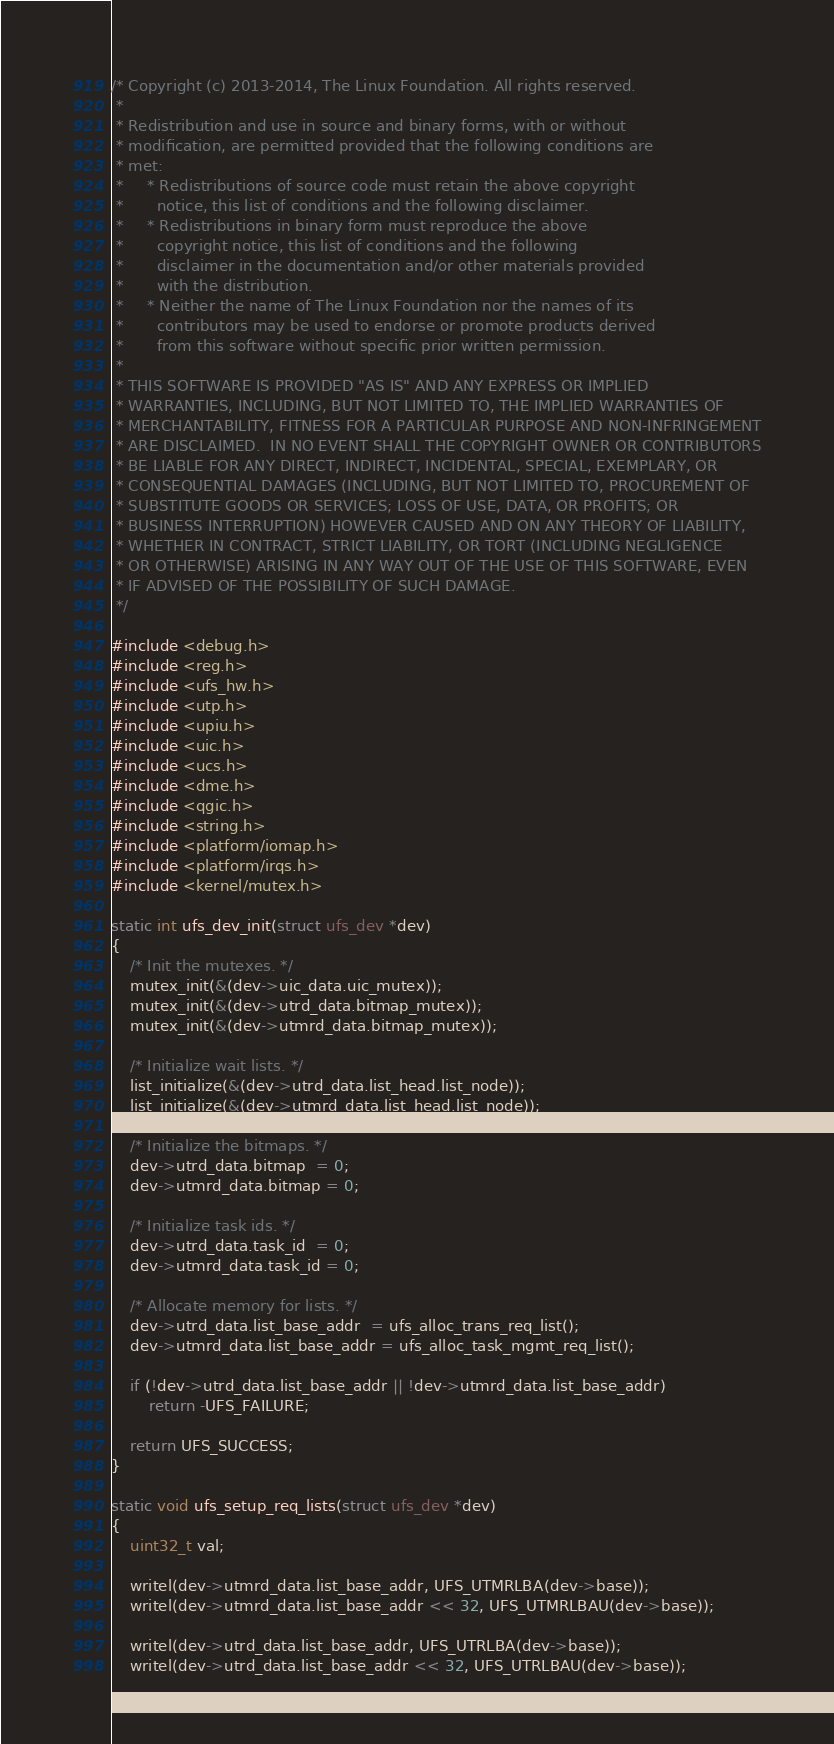<code> <loc_0><loc_0><loc_500><loc_500><_C_>/* Copyright (c) 2013-2014, The Linux Foundation. All rights reserved.
 *
 * Redistribution and use in source and binary forms, with or without
 * modification, are permitted provided that the following conditions are
 * met:
 *     * Redistributions of source code must retain the above copyright
 *       notice, this list of conditions and the following disclaimer.
 *     * Redistributions in binary form must reproduce the above
 *       copyright notice, this list of conditions and the following
 *       disclaimer in the documentation and/or other materials provided
 *       with the distribution.
 *     * Neither the name of The Linux Foundation nor the names of its
 *       contributors may be used to endorse or promote products derived
 *       from this software without specific prior written permission.
 *
 * THIS SOFTWARE IS PROVIDED "AS IS" AND ANY EXPRESS OR IMPLIED
 * WARRANTIES, INCLUDING, BUT NOT LIMITED TO, THE IMPLIED WARRANTIES OF
 * MERCHANTABILITY, FITNESS FOR A PARTICULAR PURPOSE AND NON-INFRINGEMENT
 * ARE DISCLAIMED.  IN NO EVENT SHALL THE COPYRIGHT OWNER OR CONTRIBUTORS
 * BE LIABLE FOR ANY DIRECT, INDIRECT, INCIDENTAL, SPECIAL, EXEMPLARY, OR
 * CONSEQUENTIAL DAMAGES (INCLUDING, BUT NOT LIMITED TO, PROCUREMENT OF
 * SUBSTITUTE GOODS OR SERVICES; LOSS OF USE, DATA, OR PROFITS; OR
 * BUSINESS INTERRUPTION) HOWEVER CAUSED AND ON ANY THEORY OF LIABILITY,
 * WHETHER IN CONTRACT, STRICT LIABILITY, OR TORT (INCLUDING NEGLIGENCE
 * OR OTHERWISE) ARISING IN ANY WAY OUT OF THE USE OF THIS SOFTWARE, EVEN
 * IF ADVISED OF THE POSSIBILITY OF SUCH DAMAGE.
 */

#include <debug.h>
#include <reg.h>
#include <ufs_hw.h>
#include <utp.h>
#include <upiu.h>
#include <uic.h>
#include <ucs.h>
#include <dme.h>
#include <qgic.h>
#include <string.h>
#include <platform/iomap.h>
#include <platform/irqs.h>
#include <kernel/mutex.h>

static int ufs_dev_init(struct ufs_dev *dev)
{
	/* Init the mutexes. */
	mutex_init(&(dev->uic_data.uic_mutex));
	mutex_init(&(dev->utrd_data.bitmap_mutex));
	mutex_init(&(dev->utmrd_data.bitmap_mutex));

	/* Initialize wait lists. */
	list_initialize(&(dev->utrd_data.list_head.list_node));
	list_initialize(&(dev->utmrd_data.list_head.list_node));

	/* Initialize the bitmaps. */
	dev->utrd_data.bitmap  = 0;
	dev->utmrd_data.bitmap = 0;

	/* Initialize task ids. */
	dev->utrd_data.task_id  = 0;
	dev->utmrd_data.task_id = 0;

	/* Allocate memory for lists. */
	dev->utrd_data.list_base_addr  = ufs_alloc_trans_req_list();
	dev->utmrd_data.list_base_addr = ufs_alloc_task_mgmt_req_list();

	if (!dev->utrd_data.list_base_addr || !dev->utmrd_data.list_base_addr)
		return -UFS_FAILURE;

	return UFS_SUCCESS;
}

static void ufs_setup_req_lists(struct ufs_dev *dev)
{
	uint32_t val;

	writel(dev->utmrd_data.list_base_addr, UFS_UTMRLBA(dev->base));
	writel(dev->utmrd_data.list_base_addr << 32, UFS_UTMRLBAU(dev->base));

	writel(dev->utrd_data.list_base_addr, UFS_UTRLBA(dev->base));
	writel(dev->utrd_data.list_base_addr << 32, UFS_UTRLBAU(dev->base));
</code> 